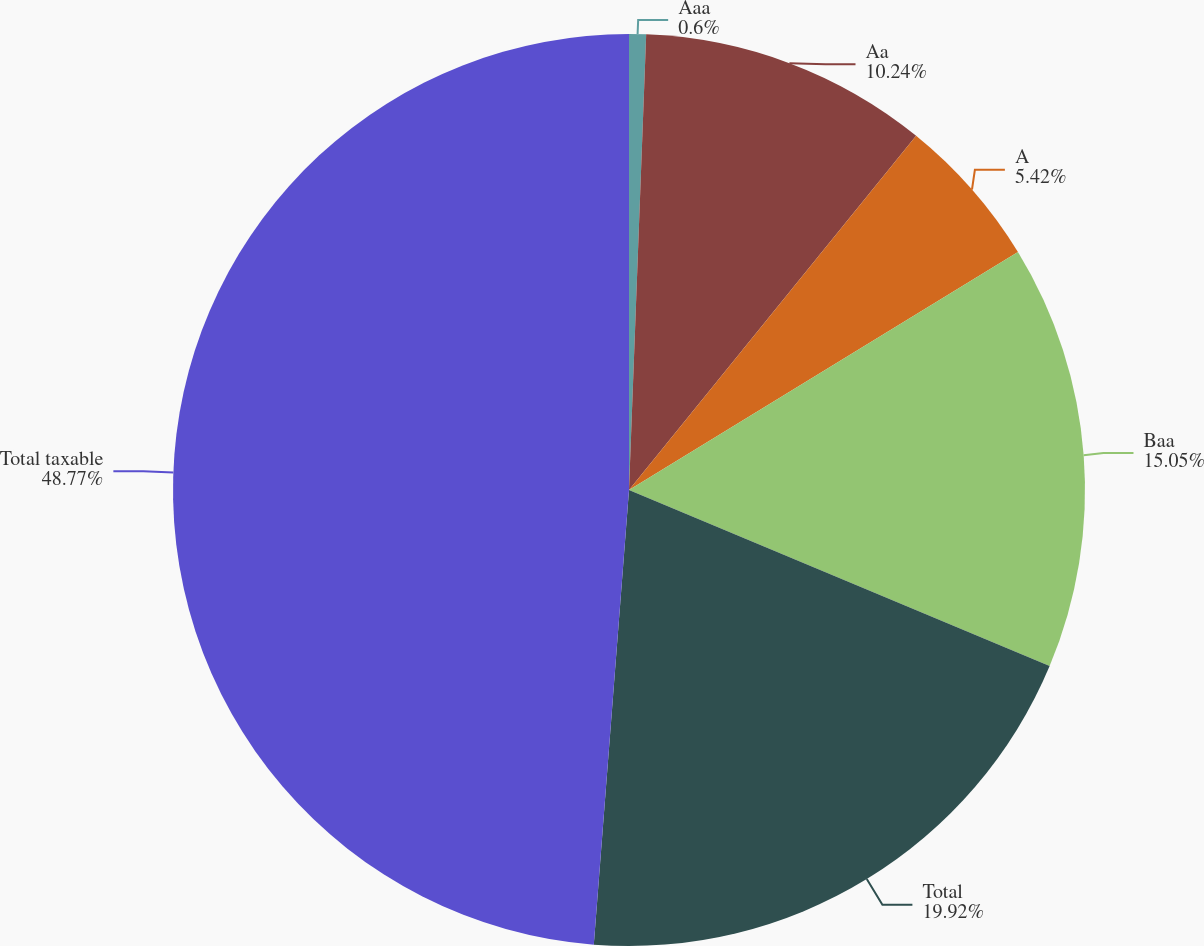Convert chart to OTSL. <chart><loc_0><loc_0><loc_500><loc_500><pie_chart><fcel>Aaa<fcel>Aa<fcel>A<fcel>Baa<fcel>Total<fcel>Total taxable<nl><fcel>0.6%<fcel>10.24%<fcel>5.42%<fcel>15.05%<fcel>19.92%<fcel>48.77%<nl></chart> 